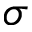<formula> <loc_0><loc_0><loc_500><loc_500>\sigma</formula> 